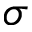<formula> <loc_0><loc_0><loc_500><loc_500>\sigma</formula> 